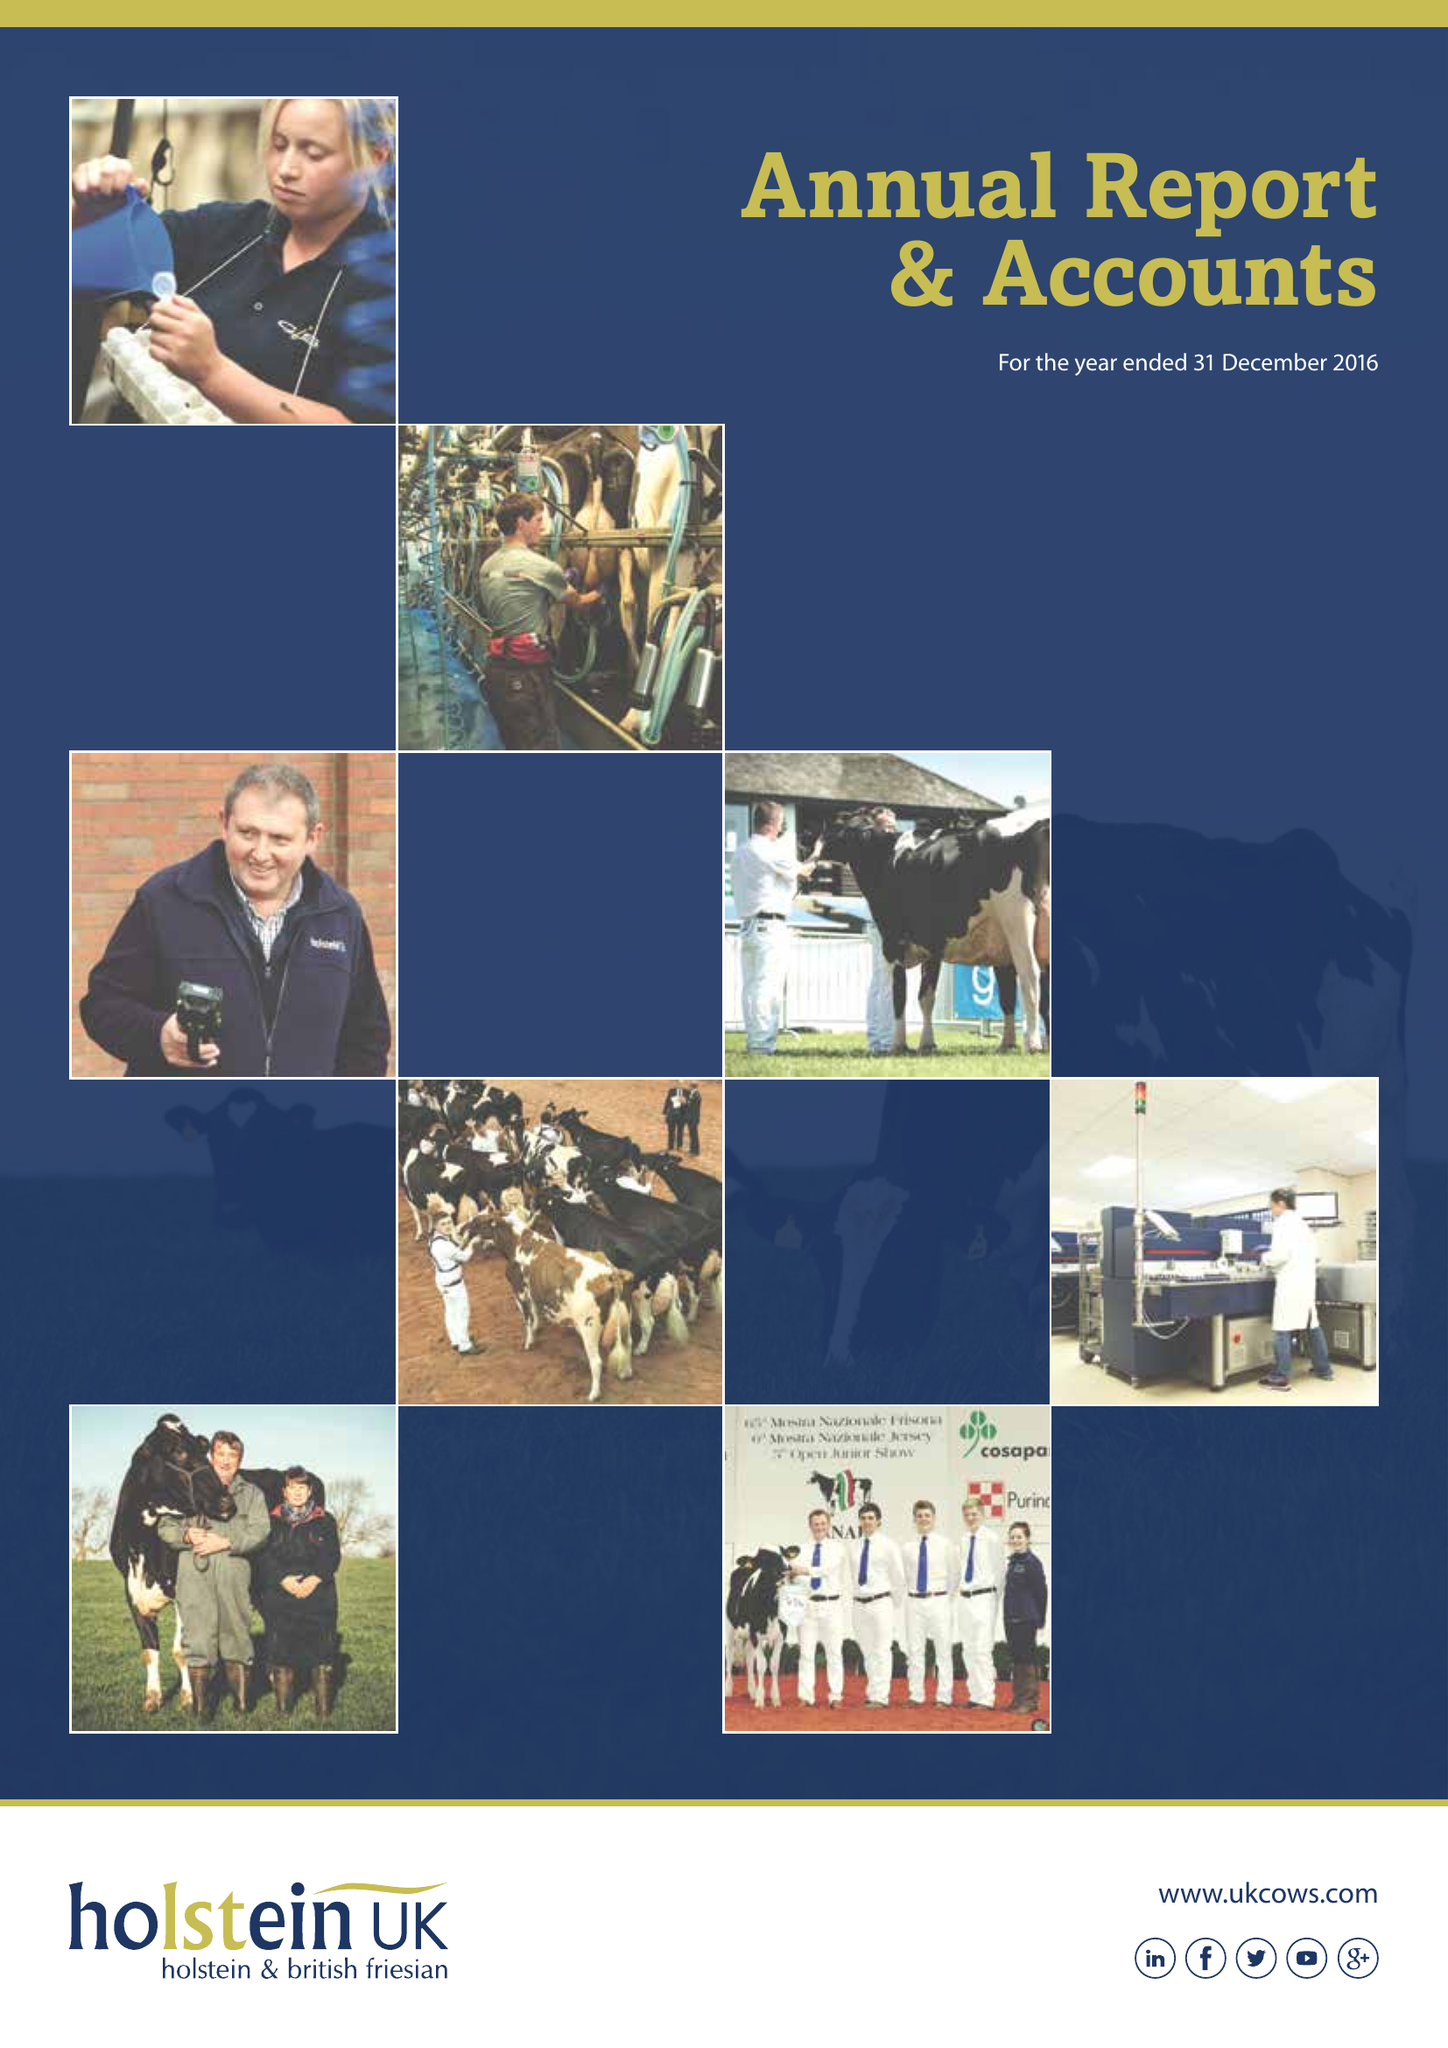What is the value for the income_annually_in_british_pounds?
Answer the question using a single word or phrase. 9566320.00 